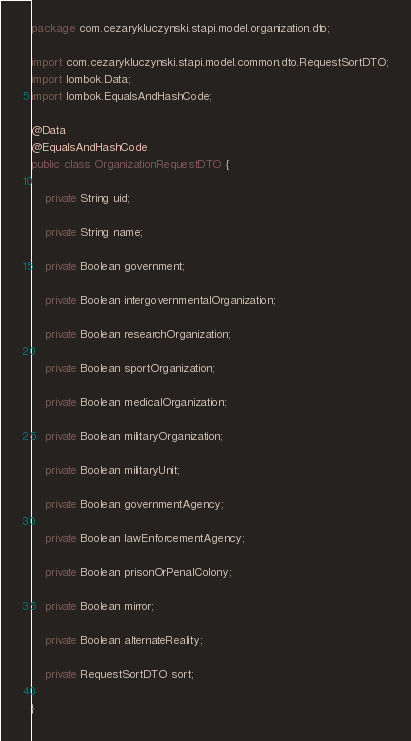Convert code to text. <code><loc_0><loc_0><loc_500><loc_500><_Java_>package com.cezarykluczynski.stapi.model.organization.dto;

import com.cezarykluczynski.stapi.model.common.dto.RequestSortDTO;
import lombok.Data;
import lombok.EqualsAndHashCode;

@Data
@EqualsAndHashCode
public class OrganizationRequestDTO {

	private String uid;

	private String name;

	private Boolean government;

	private Boolean intergovernmentalOrganization;

	private Boolean researchOrganization;

	private Boolean sportOrganization;

	private Boolean medicalOrganization;

	private Boolean militaryOrganization;

	private Boolean militaryUnit;

	private Boolean governmentAgency;

	private Boolean lawEnforcementAgency;

	private Boolean prisonOrPenalColony;

	private Boolean mirror;

	private Boolean alternateReality;

	private RequestSortDTO sort;

}
</code> 